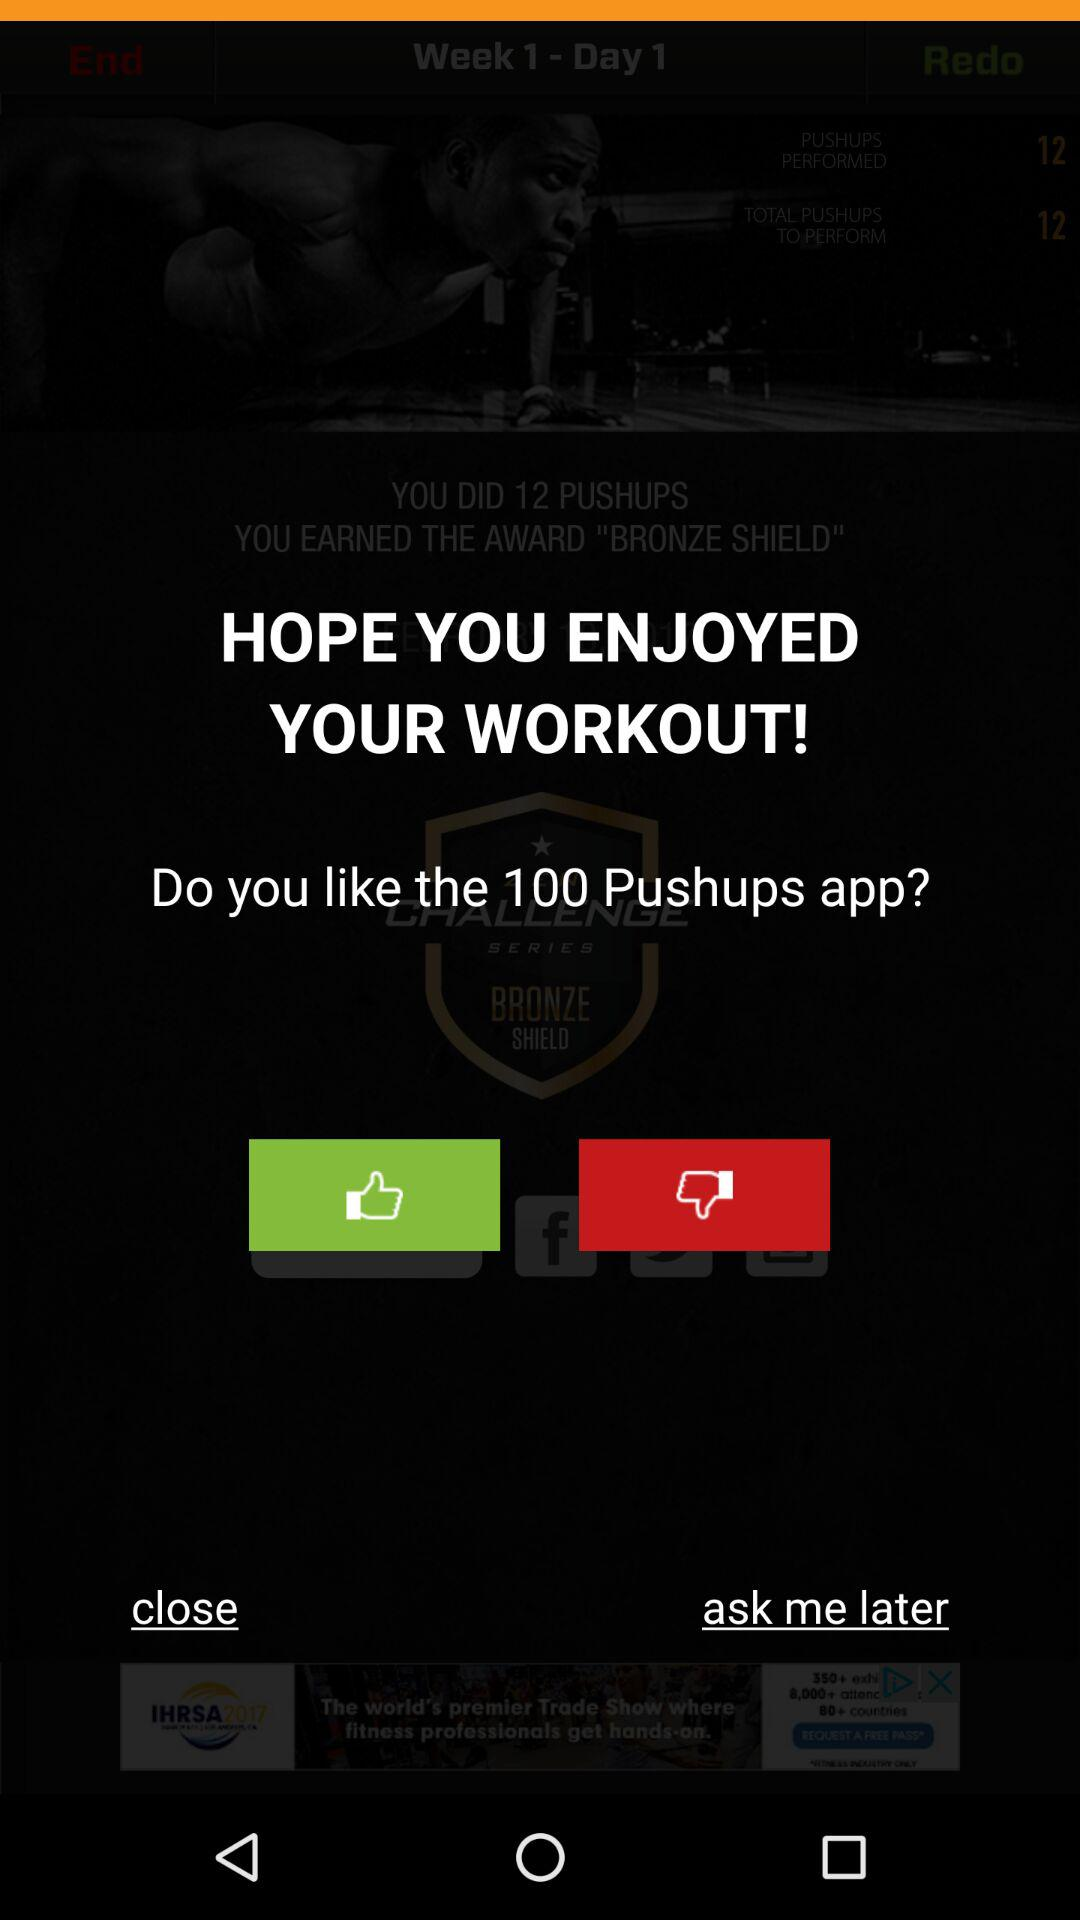What is the name of the application? The name of the application is "100 Pushups". 